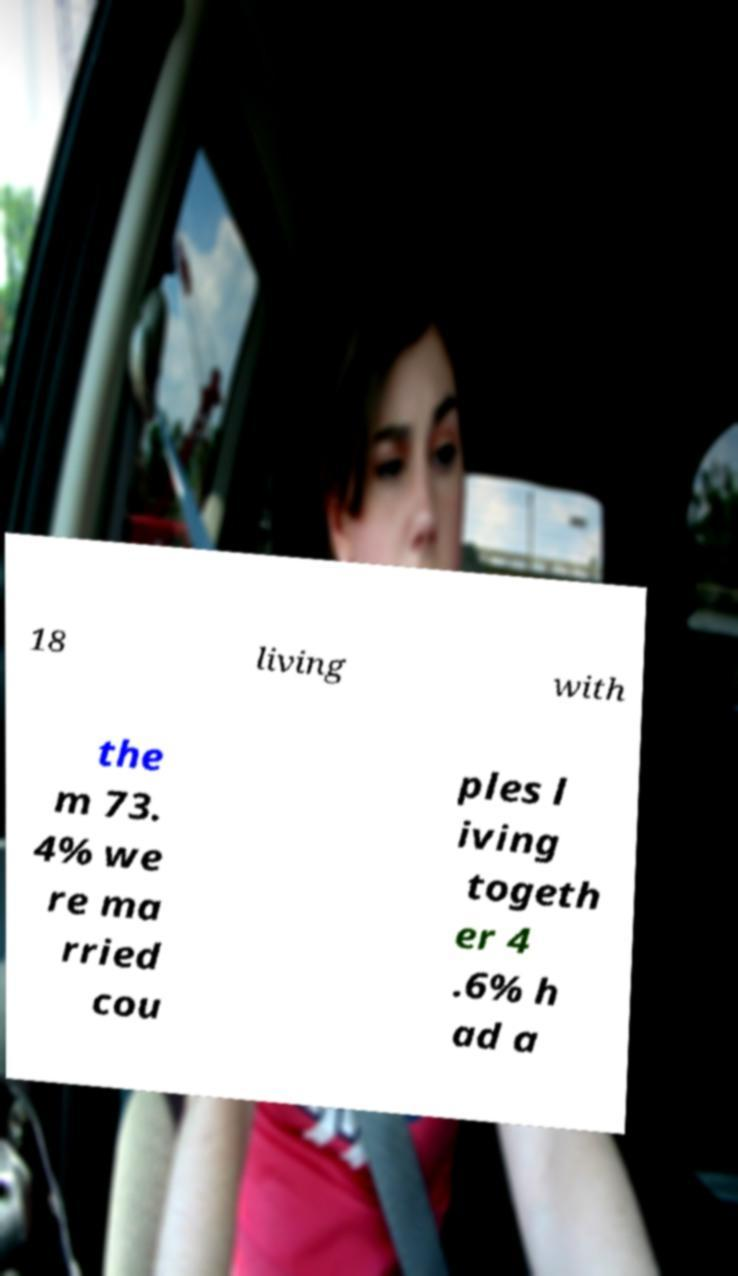There's text embedded in this image that I need extracted. Can you transcribe it verbatim? 18 living with the m 73. 4% we re ma rried cou ples l iving togeth er 4 .6% h ad a 